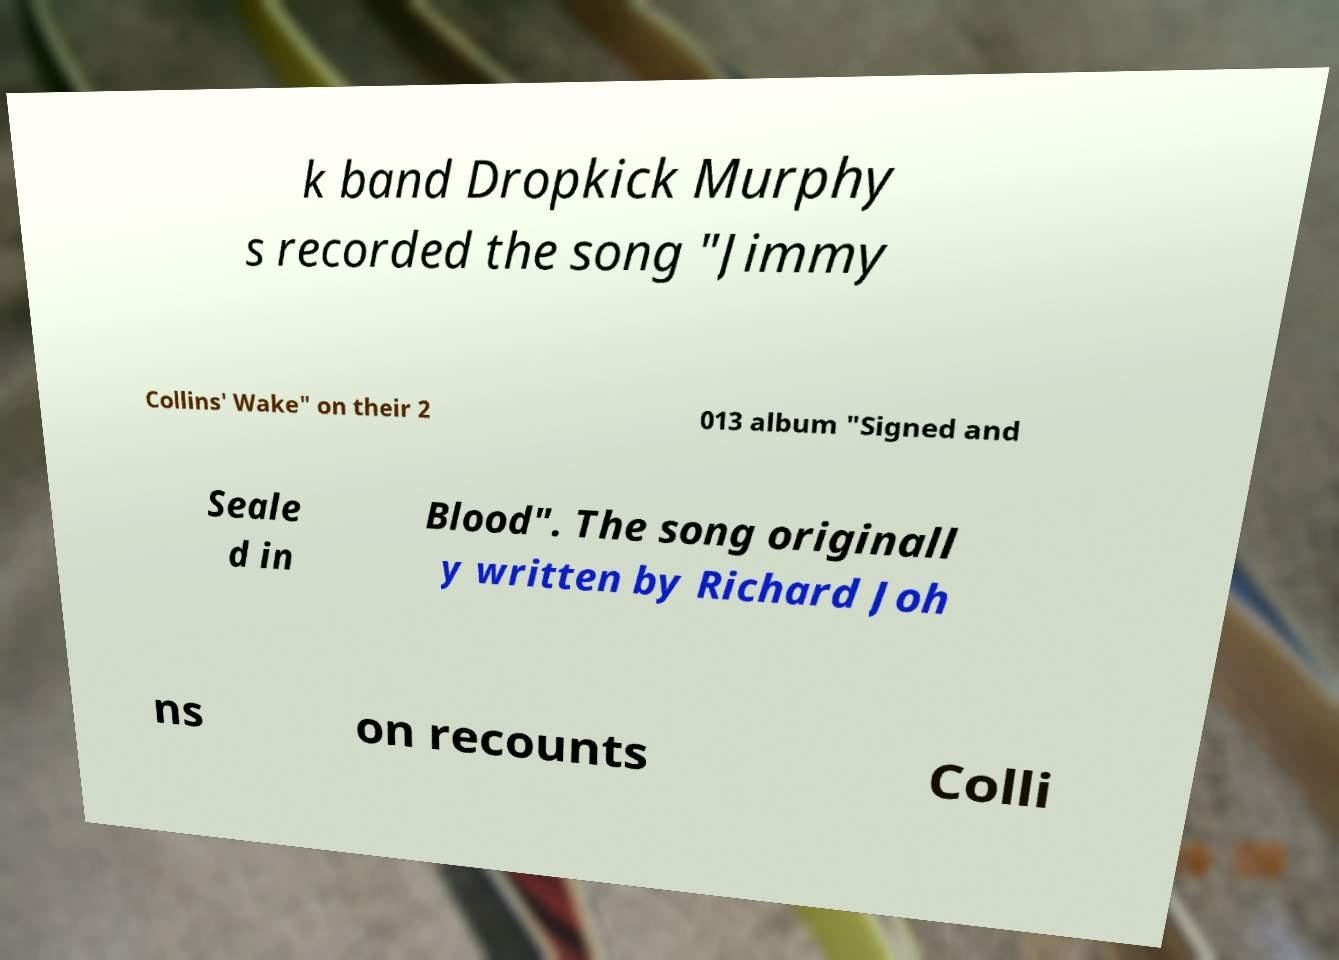For documentation purposes, I need the text within this image transcribed. Could you provide that? k band Dropkick Murphy s recorded the song "Jimmy Collins' Wake" on their 2 013 album "Signed and Seale d in Blood". The song originall y written by Richard Joh ns on recounts Colli 